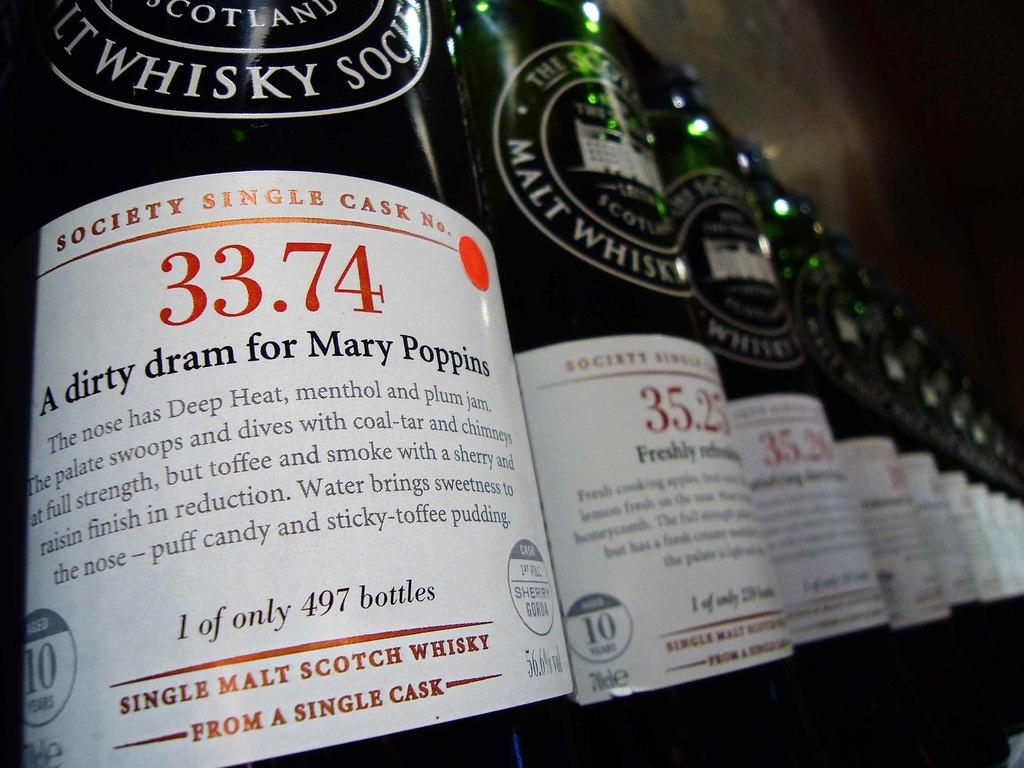What objects are present in the image? There are bottles in the image. What can be found on the bottles? The bottles have labels and clear stickers attached to them. Can you describe the background of the image? The background of the image appears blurry. Is there any quicksand visible in the image? No, there is no quicksand present in the image. How many eggs can be seen in the image? There are no eggs present in the image. Is there an airplane visible in the image? No, there is no airplane present in the image. 